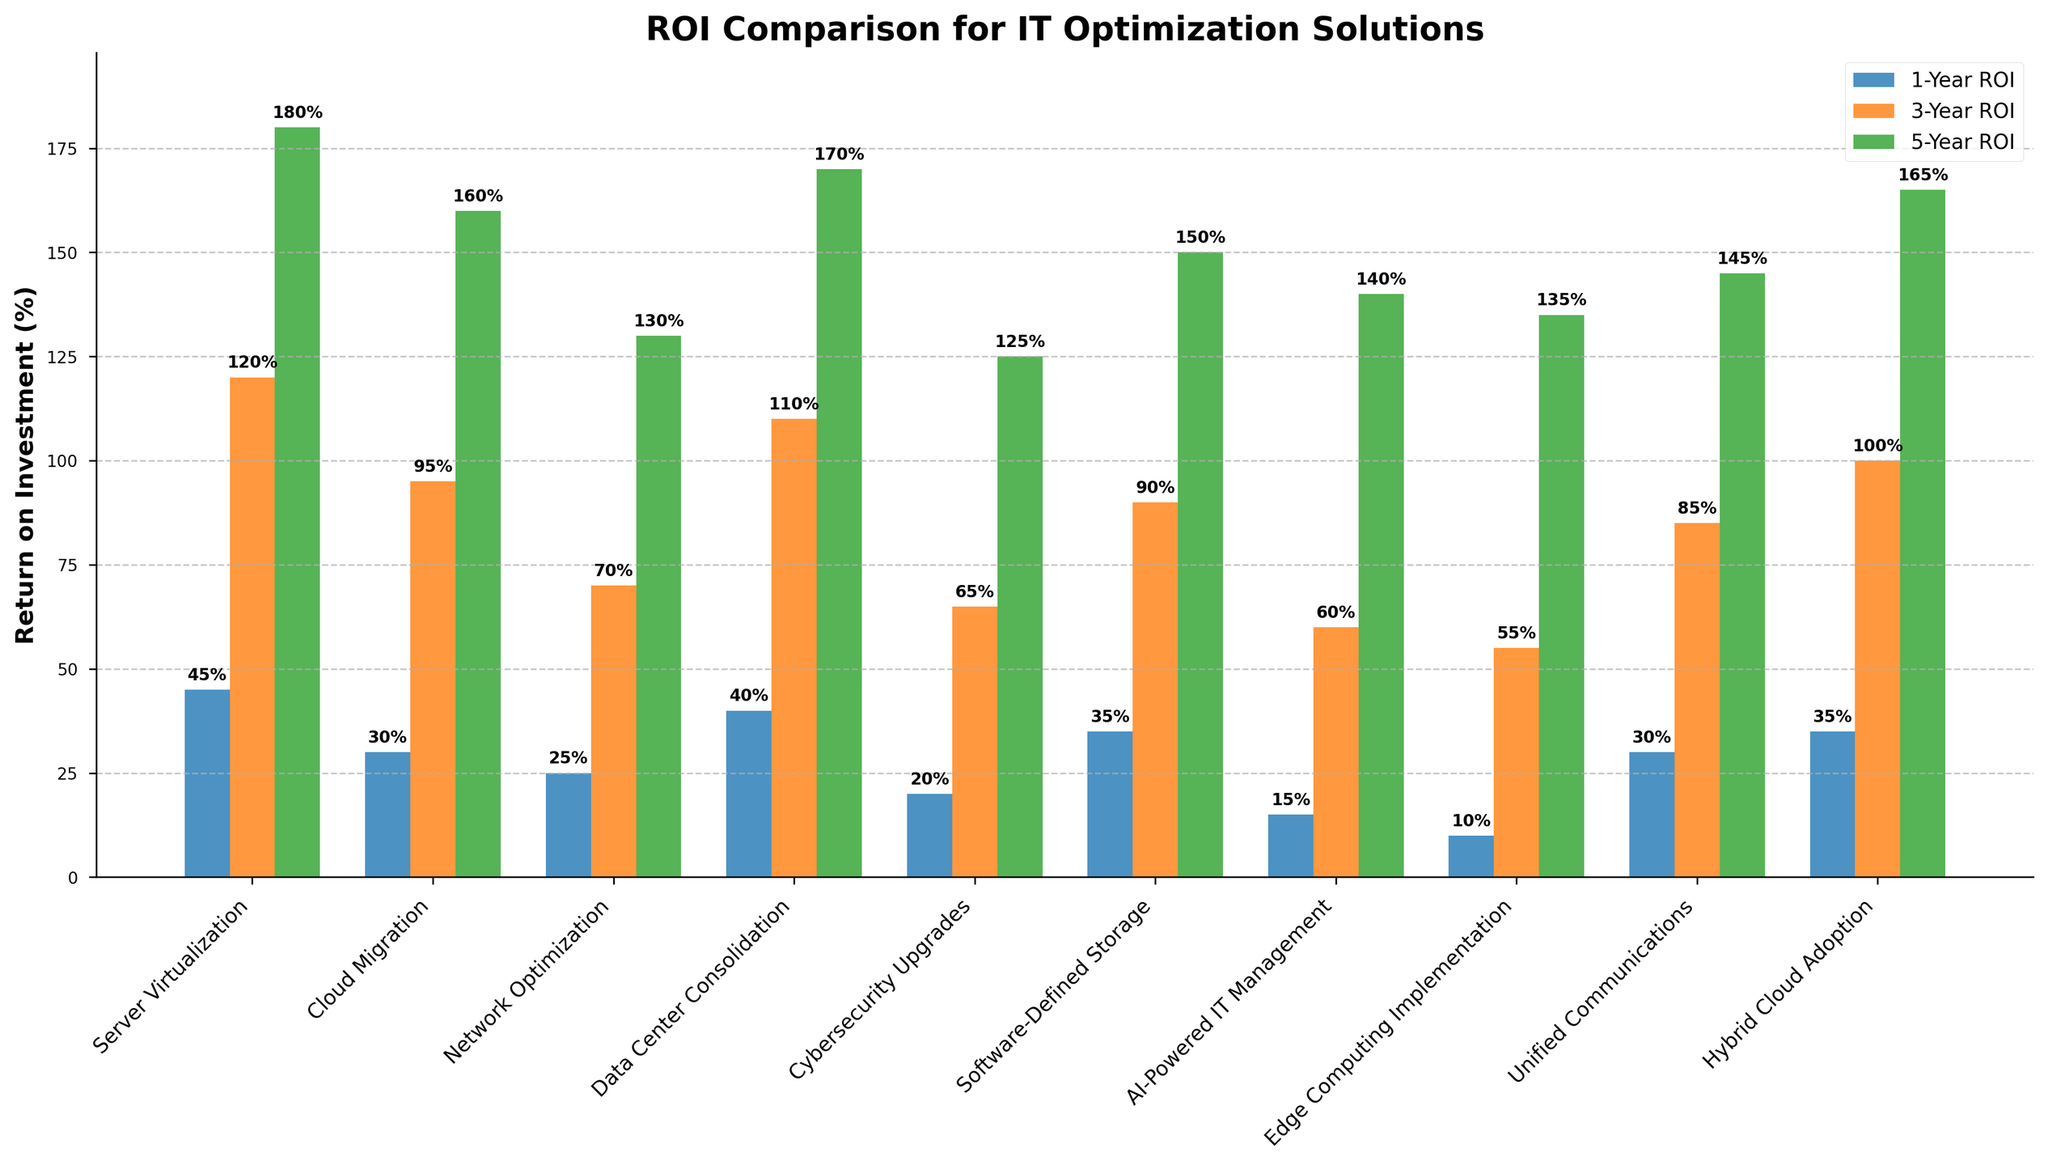What's the solution with the highest 1-Year ROI? Look at the bar with the highest height in the 1-Year ROI group (blue). The "Server Virtualization" bar is the tallest, indicating it has the highest 1-Year ROI.
Answer: Server Virtualization What's the 3-Year ROI for "Cloud Migration"? Find the orange bar corresponding to "Cloud Migration" and read the height value on the y-axis. The label shows 95%.
Answer: 95% Which solution has the lowest 5-Year ROI? Look at the shortest green bar in the 5-Year ROI group. The shortest bar corresponds to "AI-Powered IT Management".
Answer: AI-Powered IT Management How much greater is the 5-Year ROI of "Data Center Consolidation" compared to its 1-Year ROI? Subtract the height of the blue bar (1-Year ROI) for "Data Center Consolidation" from the height of the green bar (5-Year ROI). 170% - 40% = 130%.
Answer: 130% Which solution has the smallest difference between its 1-Year ROI and 3-Year ROI? Calculate the difference for each solution between the blue and orange bars, then find the smallest difference. For "AI-Powered IT Management": 60% - 15% = 45%, which is the smallest difference.
Answer: AI-Powered IT Management What’s the average 5-Year ROI across all solutions? Sum all 5-Year ROIs and divide by the number of solutions. (180 + 160 + 130 + 170 + 125 + 150 + 140 + 135 + 145 + 165) / 10 = 150%
Answer: 150% Compare the 1-Year and 5-Year ROI for "Edge Computing Implementation". Which is higher and by how much? Subtract the blue bar (1-Year) from the green bar (5-Year). 135% - 10% = 125%.
Answer: 5-Year ROI is higher by 125% Which solution has a higher 3-Year ROI: "Software-Defined Storage" or "Hybrid Cloud Adoption"? Compare the heights of the corresponding orange bars. "Hybrid Cloud Adoption" has a higher value at 100% versus 90% for "Software-Defined Storage".
Answer: Hybrid Cloud Adoption By what percentage does the 3-Year ROI of "Network Optimization" exceed its 1-Year ROI? Subtract the height of the blue bar from the orange bar for "Network Optimization". 70% - 25% = 45%.
Answer: 45% Which optimization solution shows a greater increase from 1-Year to 3-Year ROI: "Unified Communications" or "Cybersecurity Upgrades"? Calculate the difference between the blue and orange bars for each solution. "Unified Communications": 85% - 30% = 55%, "Cybersecurity Upgrades": 65% - 20% = 45%. "Unified Communications" has a greater increase.
Answer: Unified Communications 